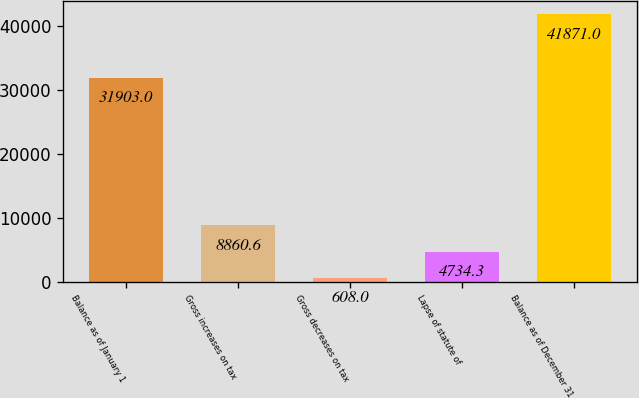Convert chart to OTSL. <chart><loc_0><loc_0><loc_500><loc_500><bar_chart><fcel>Balance as of January 1<fcel>Gross increases on tax<fcel>Gross decreases on tax<fcel>Lapse of statute of<fcel>Balance as of December 31<nl><fcel>31903<fcel>8860.6<fcel>608<fcel>4734.3<fcel>41871<nl></chart> 